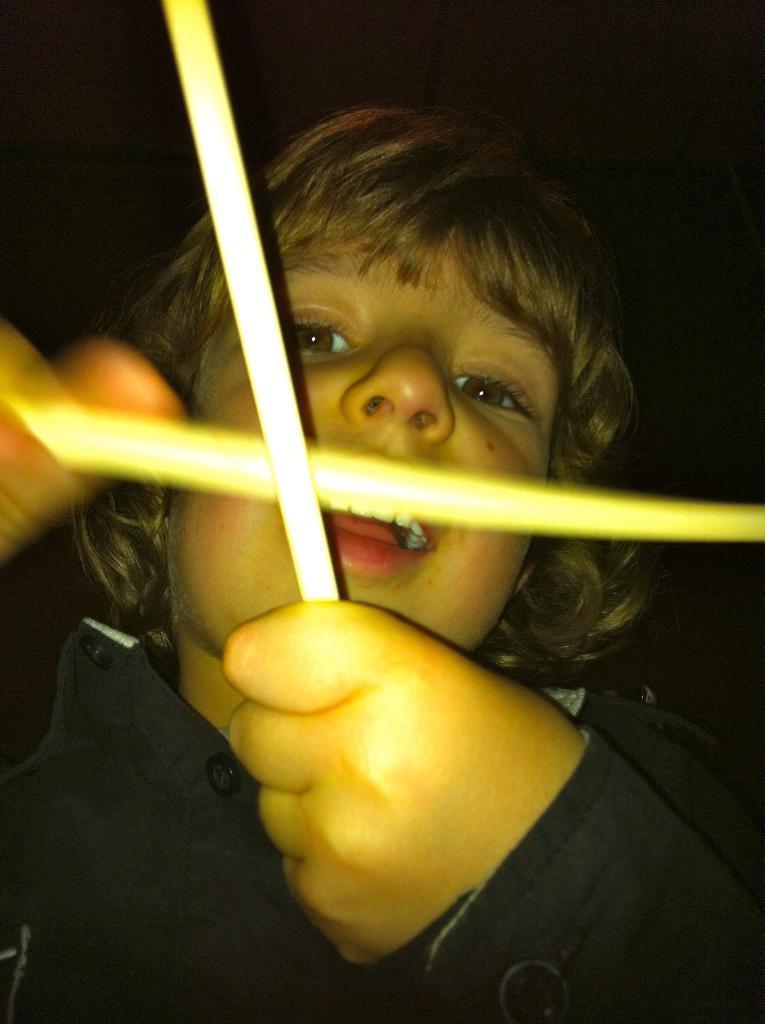Please provide a concise description of this image. This kid holding objects. Background it is dark. 